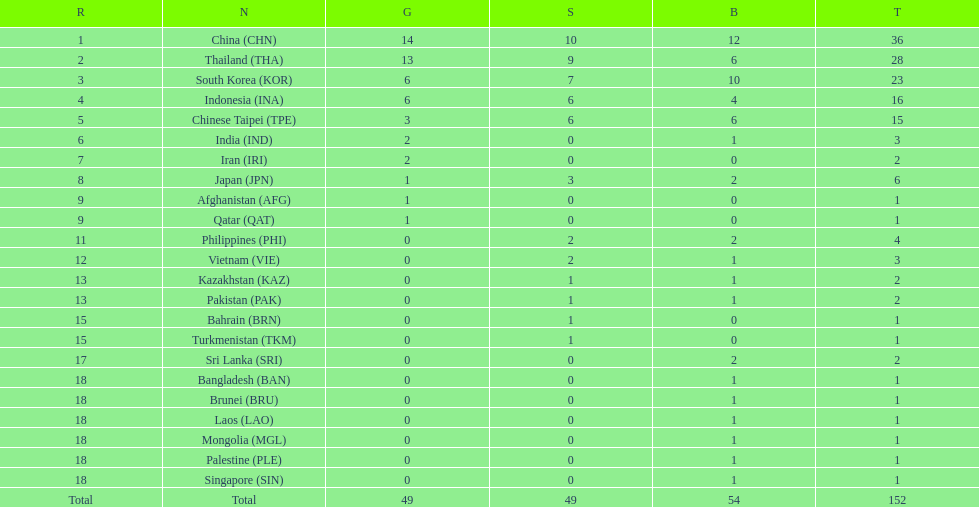Did the philippines or kazakhstan have a higher number of total medals? Philippines. 